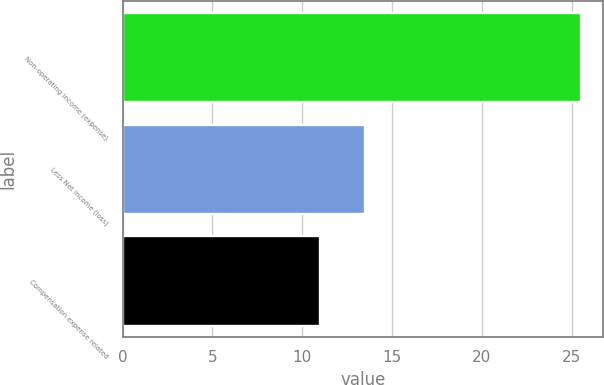Convert chart. <chart><loc_0><loc_0><loc_500><loc_500><bar_chart><fcel>Non-operating income (expense)<fcel>Less Net income (loss)<fcel>Compensation expense related<nl><fcel>25.5<fcel>13.5<fcel>11<nl></chart> 